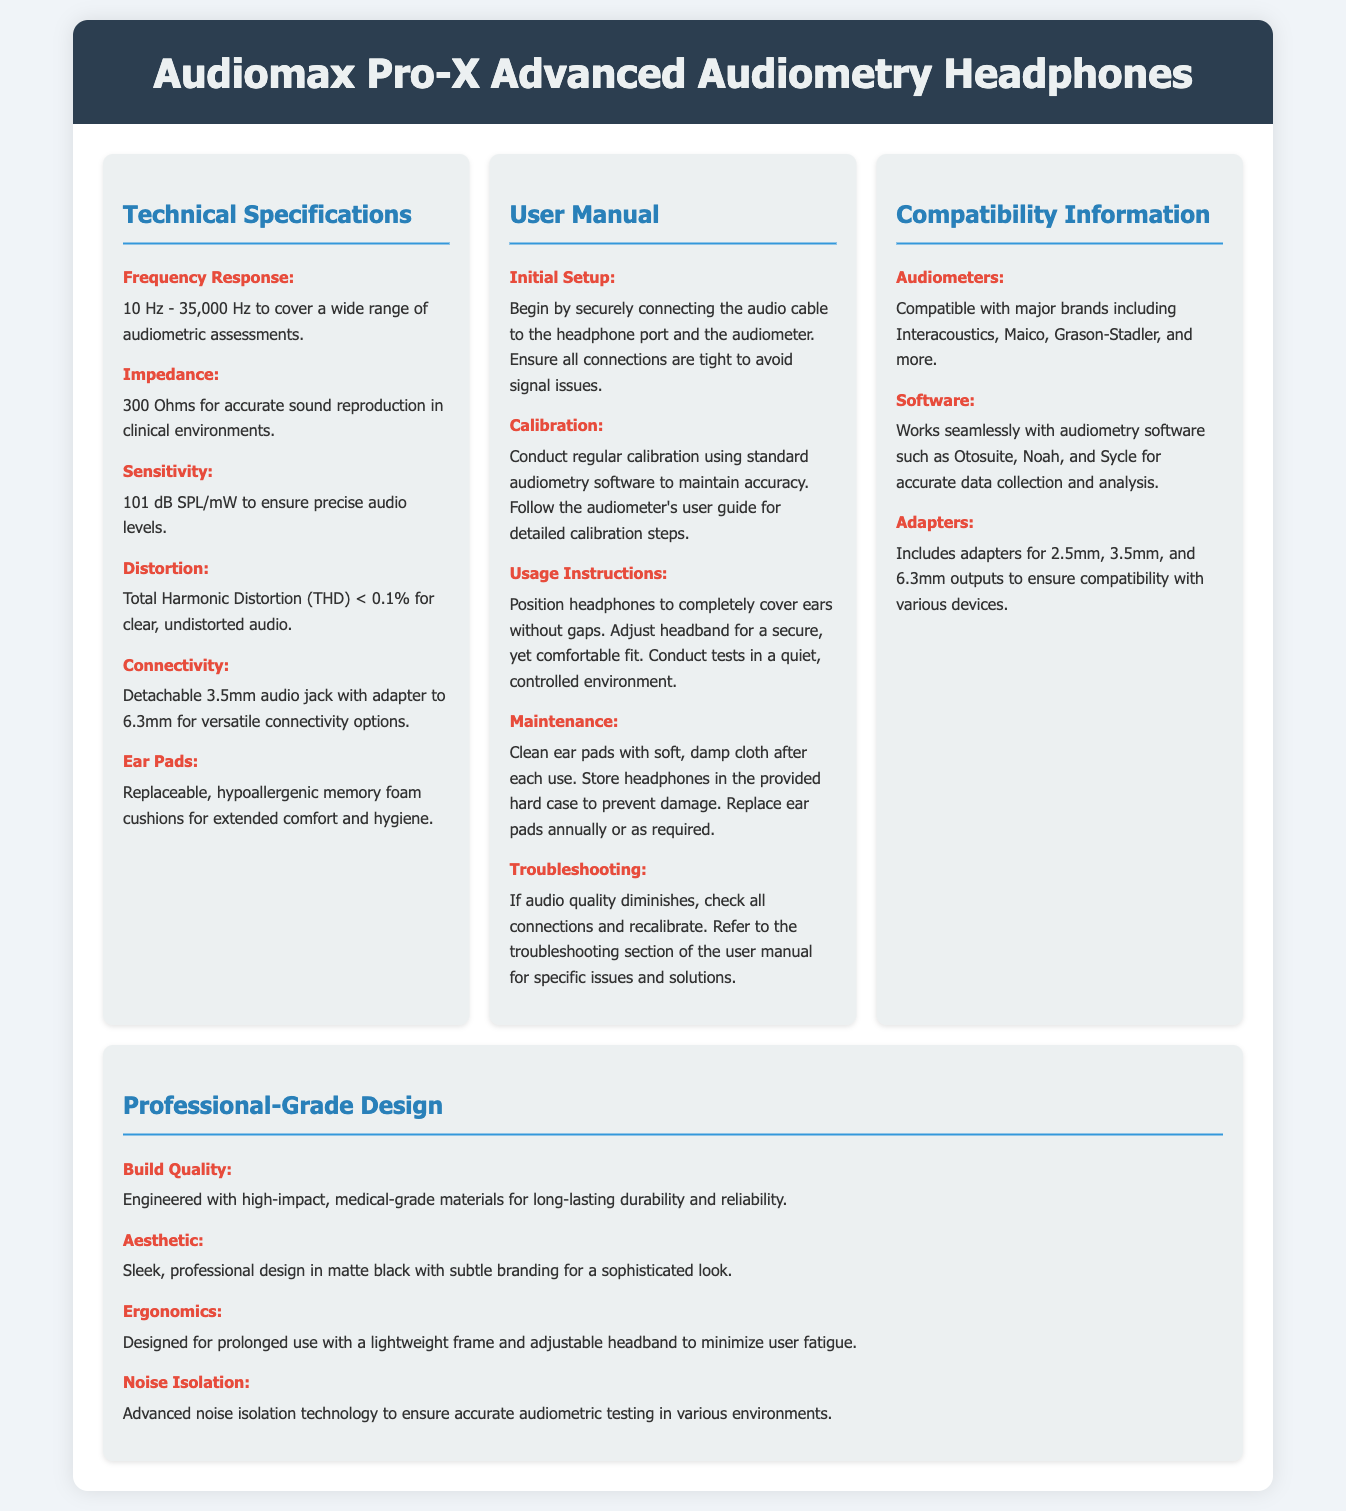What is the frequency response range? The frequency response range is specified under Technical Specifications, which states it is 10 Hz - 35,000 Hz to cover a wide range of audiometric assessments.
Answer: 10 Hz - 35,000 Hz What is the sensitivity of the headphones? The sensitivity is detailed in the Technical Specifications and is given as 101 dB SPL/mW to ensure precise audio levels.
Answer: 101 dB SPL/mW What material is used for ear pads? The User Manual describes the ear pads as replaceable, hypoallergenic memory foam cushions for extended comfort and hygiene.
Answer: Hypoallergenic memory foam How often should ear pads be replaced? According to the User Manual under Maintenance, ear pads should be replaced annually or as required.
Answer: Annually Which audiometer brands are compatible with these headphones? The Compatibility Information states compatibility with major brands including Interacoustics, Maico, Grason-Stadler, and more.
Answer: Interacoustics, Maico, Grason-Stadler What technology is implemented for noise isolation? The Professional-Grade Design section highlights the advanced noise isolation technology to ensure accurate audiometric testing in various environments.
Answer: Advanced noise isolation technology What is the total harmonic distortion (THD)? Under Technical Specifications, the total harmonic distortion is specified as THD < 0.1% for clear, undistorted audio.
Answer: THD < 0.1% What kind of maintenance is recommended for the headphones? The User Manual advises cleaning ear pads with a soft, damp cloth after each use and storing them in the provided hard case.
Answer: Clean after each use, store in case What is the design color of the headphones? The Professional-Grade Design section mentions the aesthetic as a sleek, professional design in matte black with subtle branding for a sophisticated look.
Answer: Matte black 